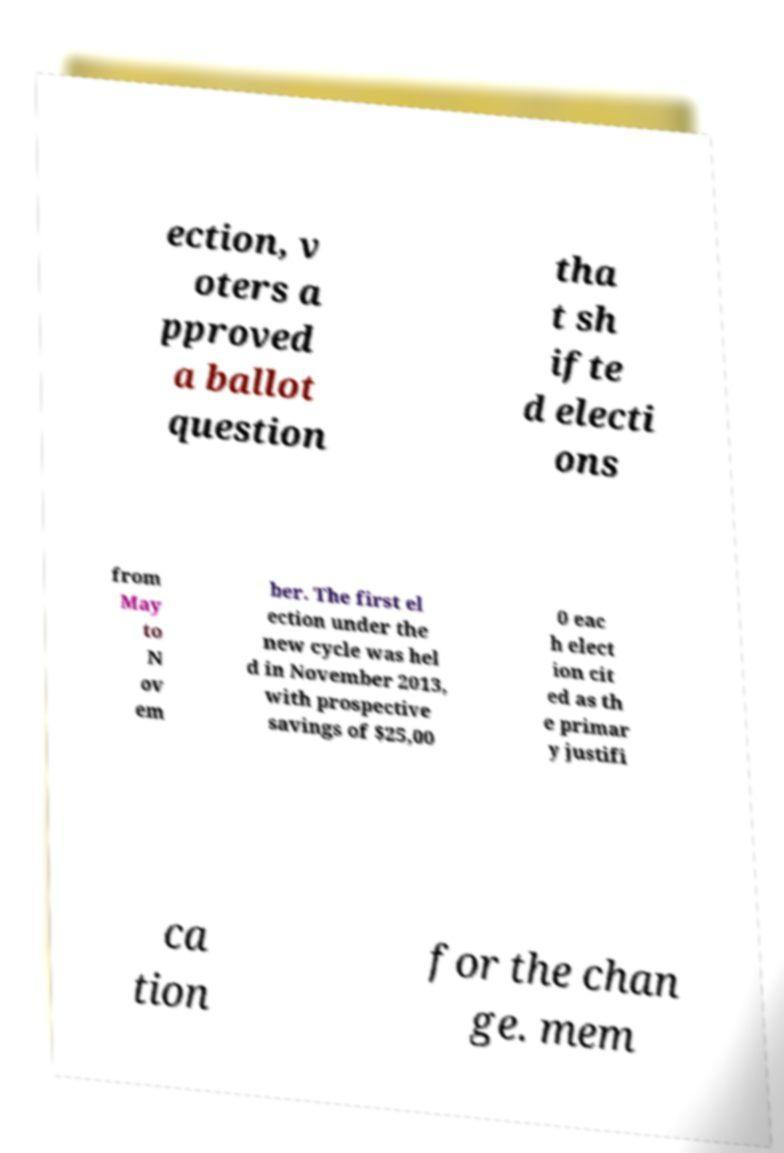There's text embedded in this image that I need extracted. Can you transcribe it verbatim? ection, v oters a pproved a ballot question tha t sh ifte d electi ons from May to N ov em ber. The first el ection under the new cycle was hel d in November 2013, with prospective savings of $25,00 0 eac h elect ion cit ed as th e primar y justifi ca tion for the chan ge. mem 